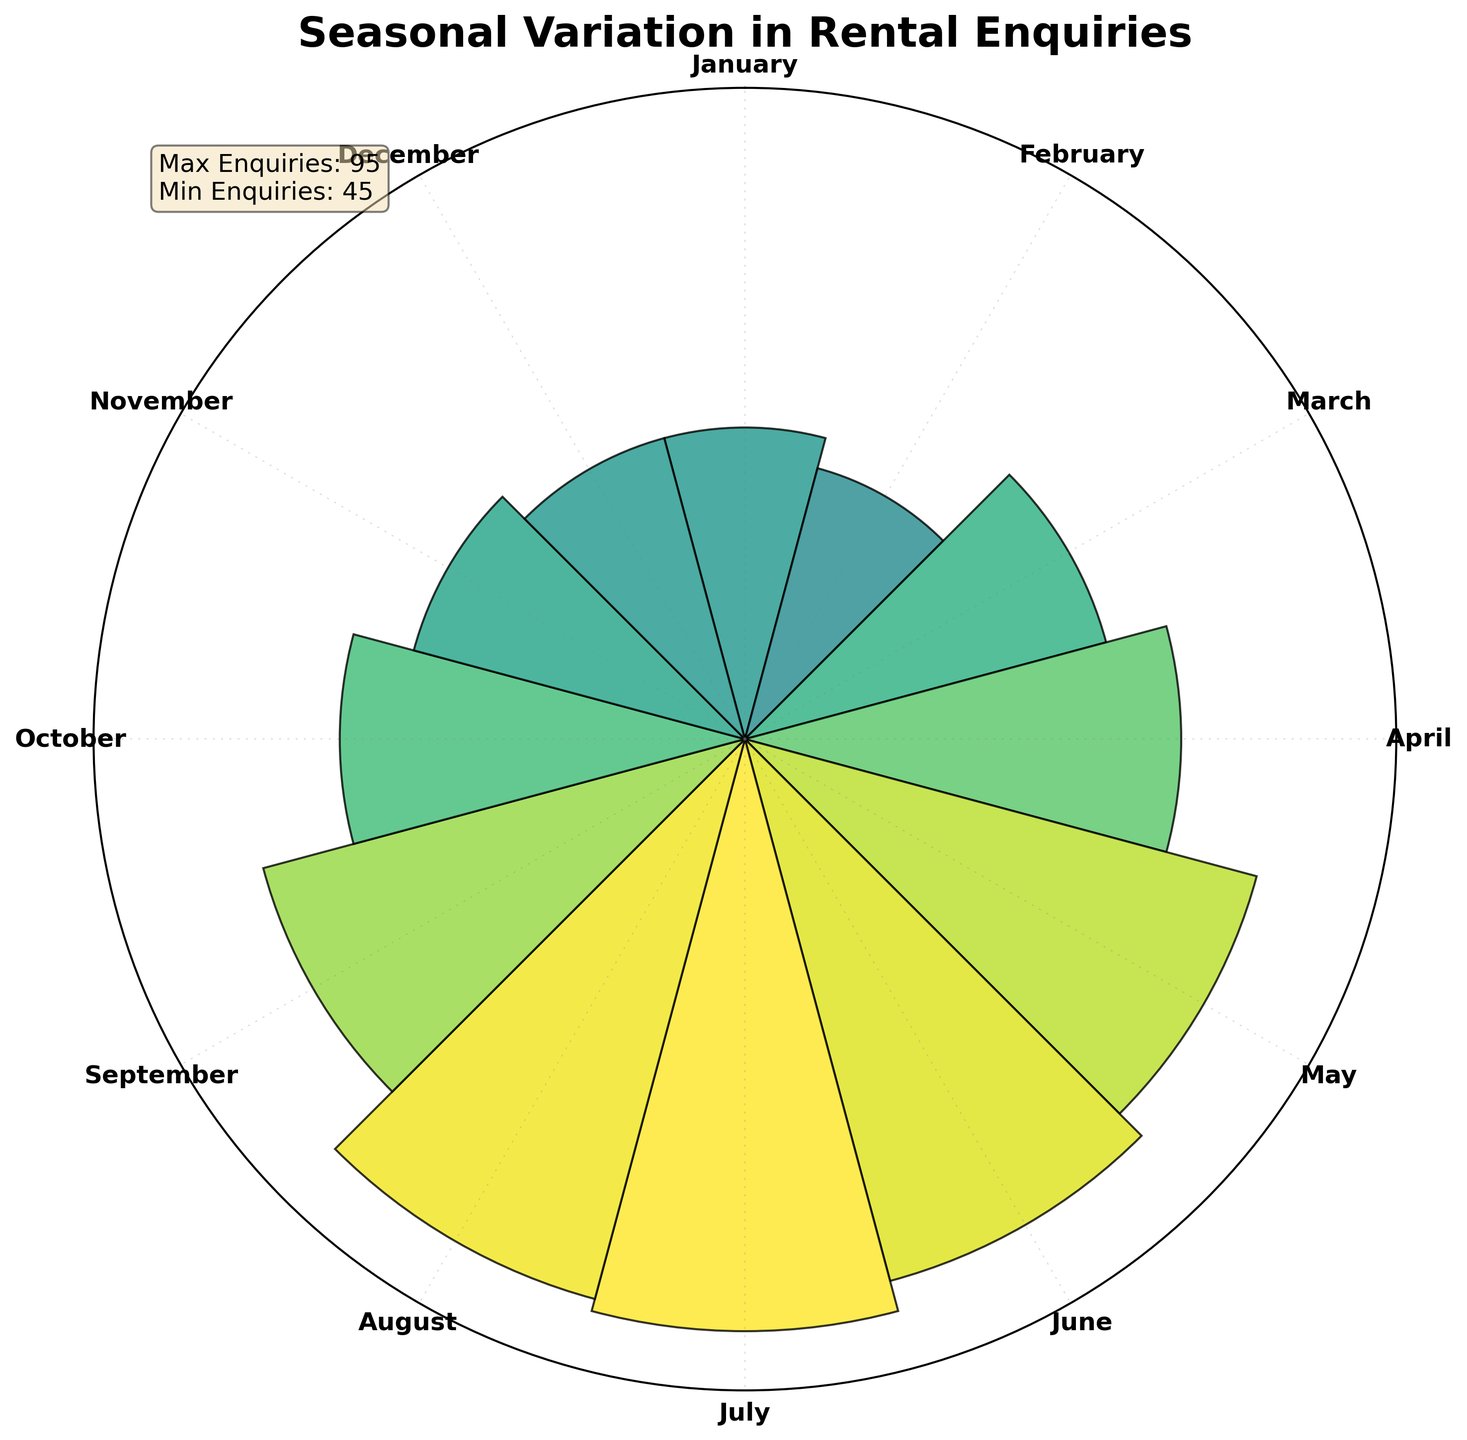What is the title of the plot? The title is usually displayed prominently at the top of the figure. It is designed to give a quick understanding of what the figure represents.
Answer: Seasonal Variation in Rental Enquiries Which month has the highest number of rental enquiries? To find the month with the highest number of rental enquiries, look for the bar that extends the furthest from the center. Comparing all bars indicates that July has the highest bar.
Answer: July What is the lowest number of rental enquiries and which month does it represent? Identify the shortest bar in the rose chart, which represents the minimum value. The shortest bars correspond to January and December, each having 50 enquiries.
Answer: 50 in January and December How do the number of enquiries in April compare to those in October? Find the bars corresponding to April and October. The bar for April is longer than that of October. April has 70 enquiries, while October has 65.
Answer: April: 70, October: 65 What is the difference between the highest and lowest number of rental enquiries? The highest number of enquiries is in July (95) and the lowest is in January and December (both 50). The difference is calculated as 95 - 50.
Answer: 45 What pattern do you observe in the number of rental enquiries throughout the year? By observing the bars' lengths around the circle, the rental enquiries tend to increase from January to July and slightly decrease towards the end of the year.
Answer: Increase until July, then decrease Are there any months with similar numbers of enquiries? The bars for January and December are roughly the same length, indicating similar values. Both months have 50 enquiries.
Answer: January and December On average, how many rental enquiries were there per month in the first half of the year (January to June)? Sum the number of enquiries for each month from January to June (50 + 45 + 60 + 70 + 85 + 90) and divide by the number of months (6). The calculation yields (400 / 6) = 66.67.
Answer: 66.67 Which month's rental enquiries are closest to the average for the year? First, calculate the average number of enquiries for the entire year: (50 + 45 + 60 + 70 + 85 + 90 + 95 + 93 + 80 + 65 + 55 + 50) / 12, which is approximately 70. Then, find the month with the number closest to 70—April is the closest with 70 enquiries.
Answer: April 